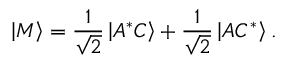Convert formula to latex. <formula><loc_0><loc_0><loc_500><loc_500>\left | M \right \rangle = \frac { 1 } { \sqrt { 2 } } \left | A ^ { * } C \right \rangle + \frac { 1 } { \sqrt { 2 } } \left | A C ^ { * } \right \rangle .</formula> 